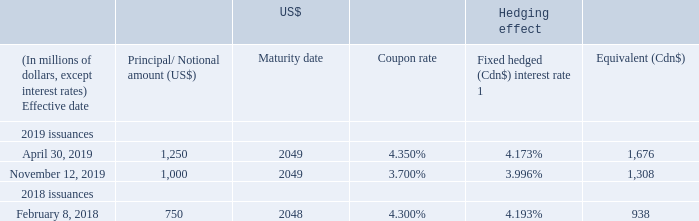DEBT DERIVATIVES
We use cross-currency interest rate agreements (debt derivatives) to manage risks from fluctuations in foreign exchange rates associated with our US dollar-denominated senior notes and debentures, lease liabilities, credit facility borrowings, and US CP borrowings. We designate the debt derivatives related to our senior notes and debentures and lease liabilities as hedges for accounting purposes against the foreign exchange risk associated with specific debt instruments. Debt derivatives related to our credit facility and US CP borrowings have not been designated as hedges for accounting purposes.
1 Converting from a fixed US$ coupon rate to a weighted average Cdn$ fixed rate.
Settlement of debt derivatives related to senior notes We did not settle any debt derivatives related to senior notes during 2019.
In April 2018, we settled the debt derivatives related to the repayment of the entire outstanding principal amount of our US$1.4 billion ($1.8 billion) 6.8% senior notes otherwise due in August 2018. See “Sources and Uses of Cash” for more information.
How many debt derivatives related to senior notes during 2019 were settled? We did not settle any debt derivatives related to senior notes during 2019. When were the debt derivatives related to the repayment due? August 2018. What was the hedge interest rate in April 30, 2019? 4.173%. What was the increase / (decrease) in the coupon rate from November 12, 2019 to April 30, 2019?
Answer scale should be: percent. 3.996% - 4.173%
Answer: -0.18. What was the increase / (decrease) in the Equivalent (Cdn$) between 2018 and November 2019?
Answer scale should be: million. 1,308 - 938
Answer: 370. What was the average Principal/ Notional amount in 2019?
Answer scale should be: million. (1,250 + 1,000) / 2
Answer: 1125. 